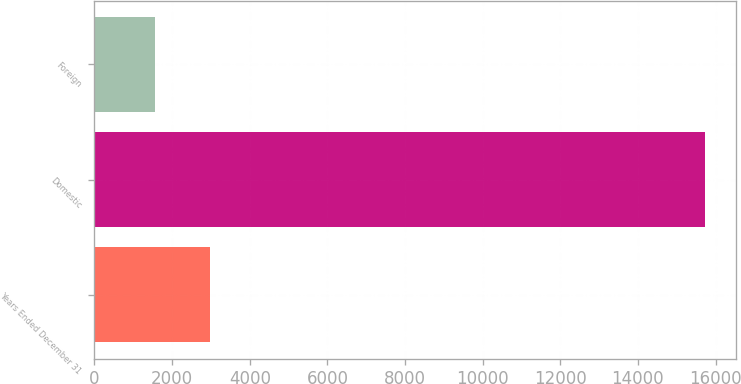Convert chart to OTSL. <chart><loc_0><loc_0><loc_500><loc_500><bar_chart><fcel>Years Ended December 31<fcel>Domestic<fcel>Foreign<nl><fcel>2970.7<fcel>15730<fcel>1553<nl></chart> 